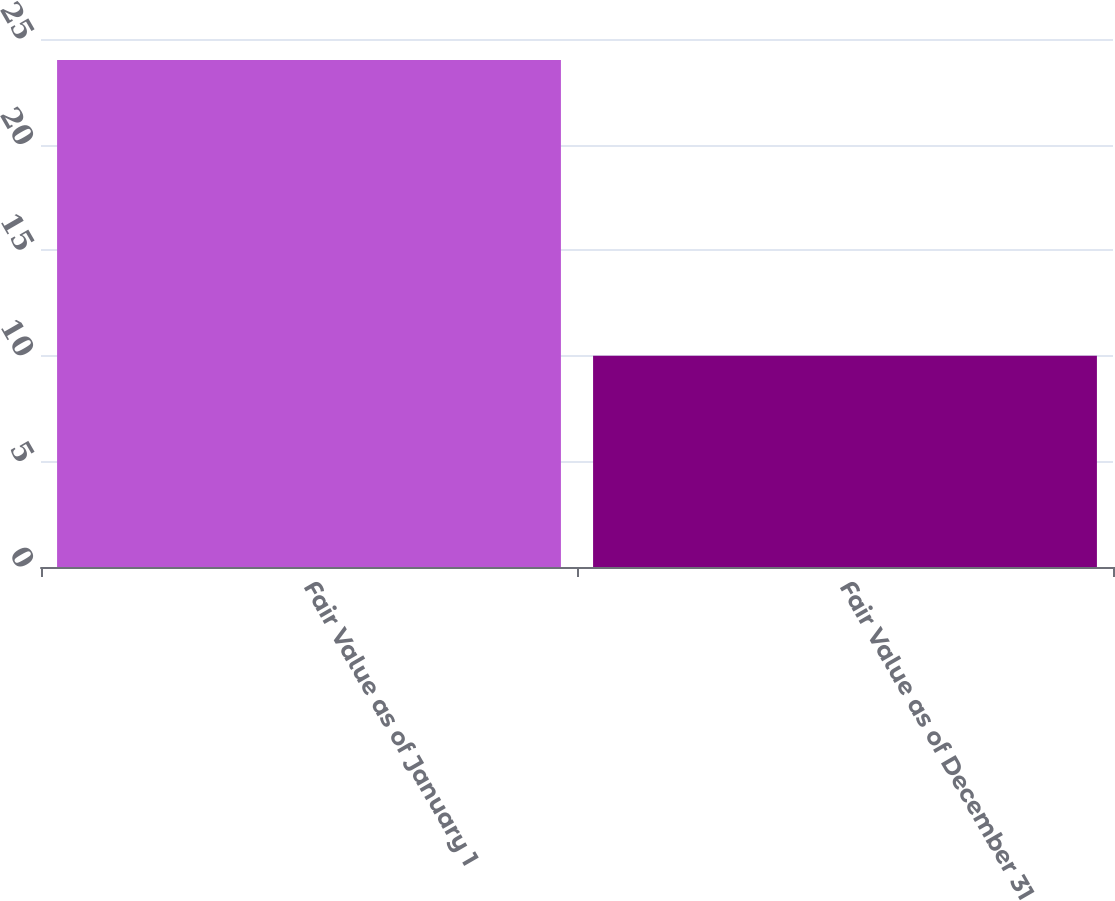Convert chart to OTSL. <chart><loc_0><loc_0><loc_500><loc_500><bar_chart><fcel>Fair Value as of January 1<fcel>Fair Value as of December 31<nl><fcel>24<fcel>10<nl></chart> 